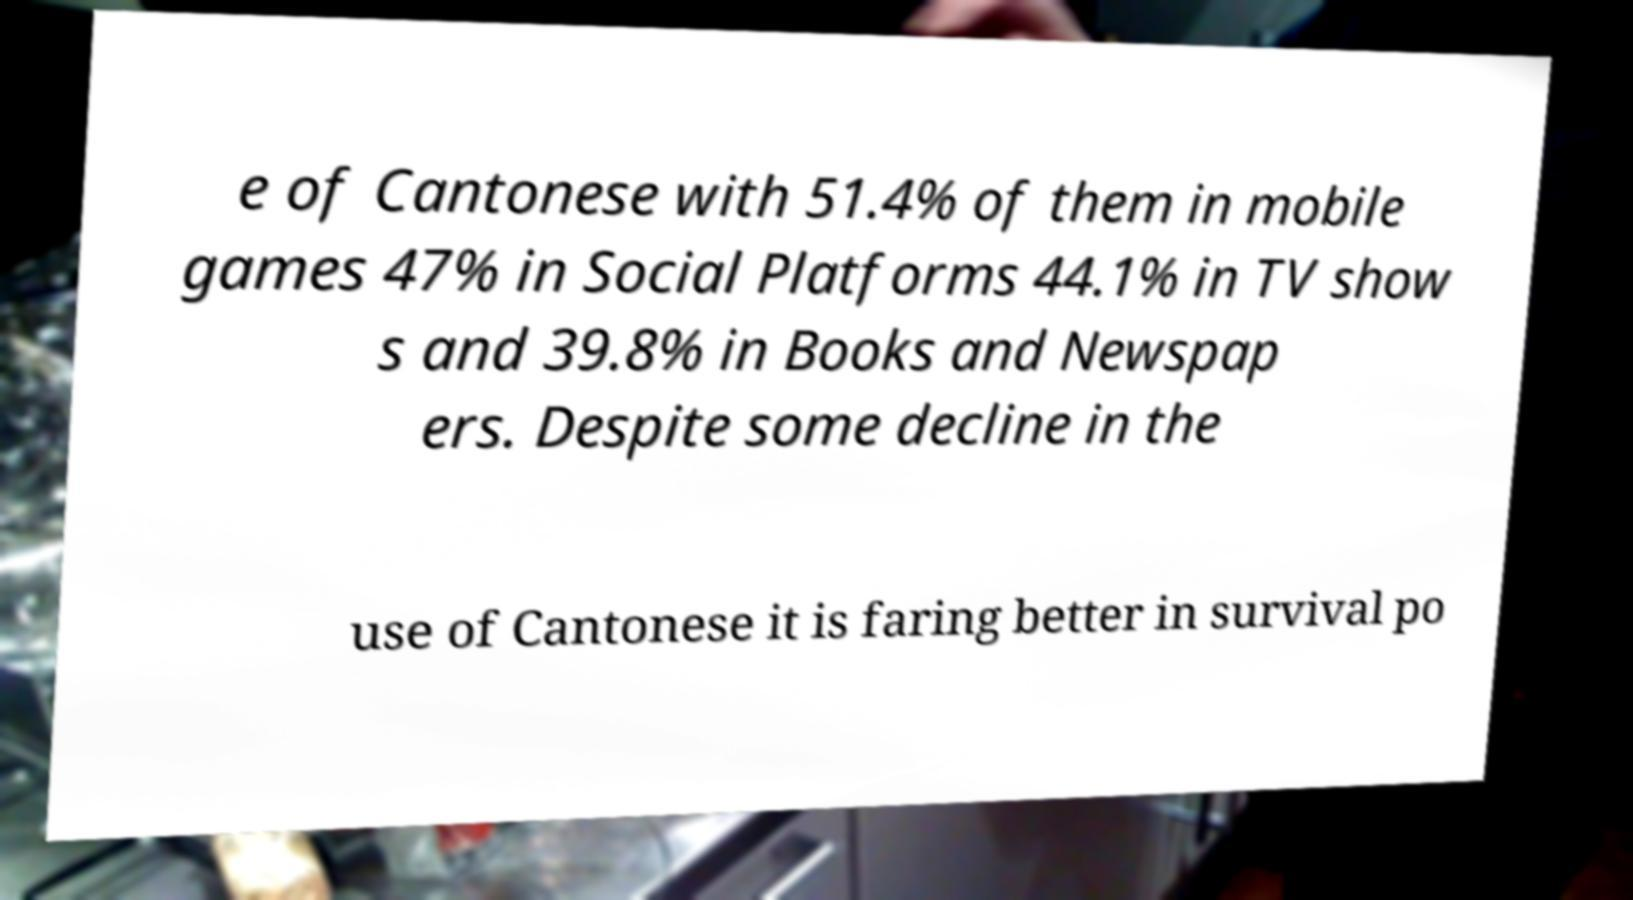Please identify and transcribe the text found in this image. e of Cantonese with 51.4% of them in mobile games 47% in Social Platforms 44.1% in TV show s and 39.8% in Books and Newspap ers. Despite some decline in the use of Cantonese it is faring better in survival po 